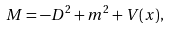<formula> <loc_0><loc_0><loc_500><loc_500>M = - D ^ { 2 } + m ^ { 2 } + V ( x ) ,</formula> 